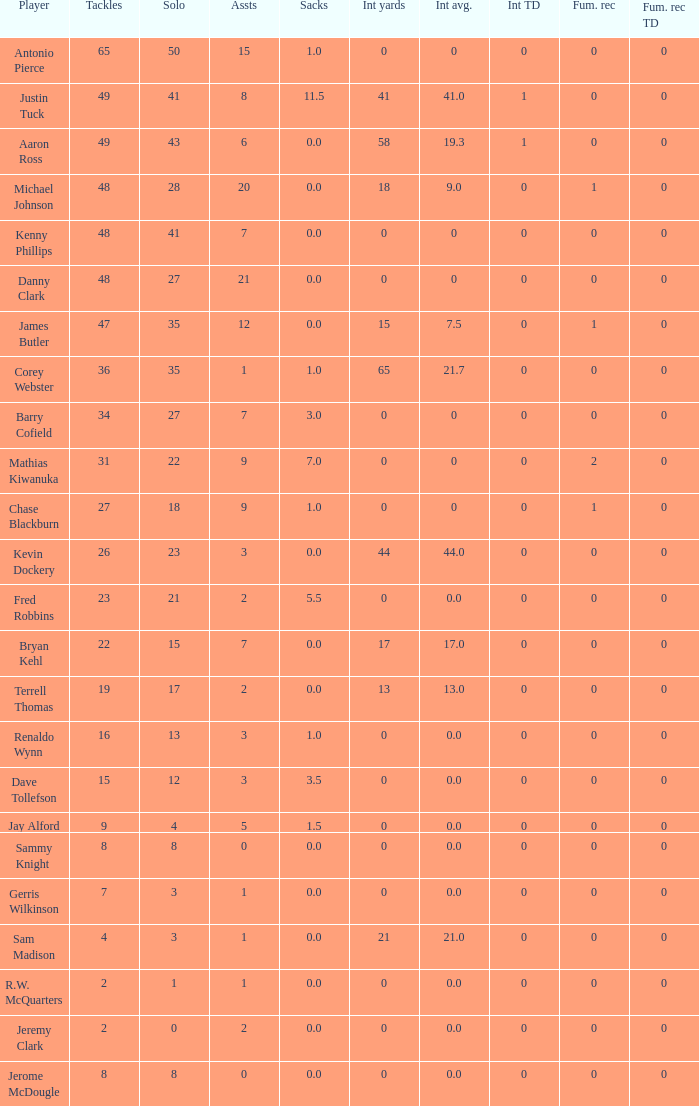What is the aggregate for the whole number yards that has assists beyond 3, and player jay alford? 0.0. 